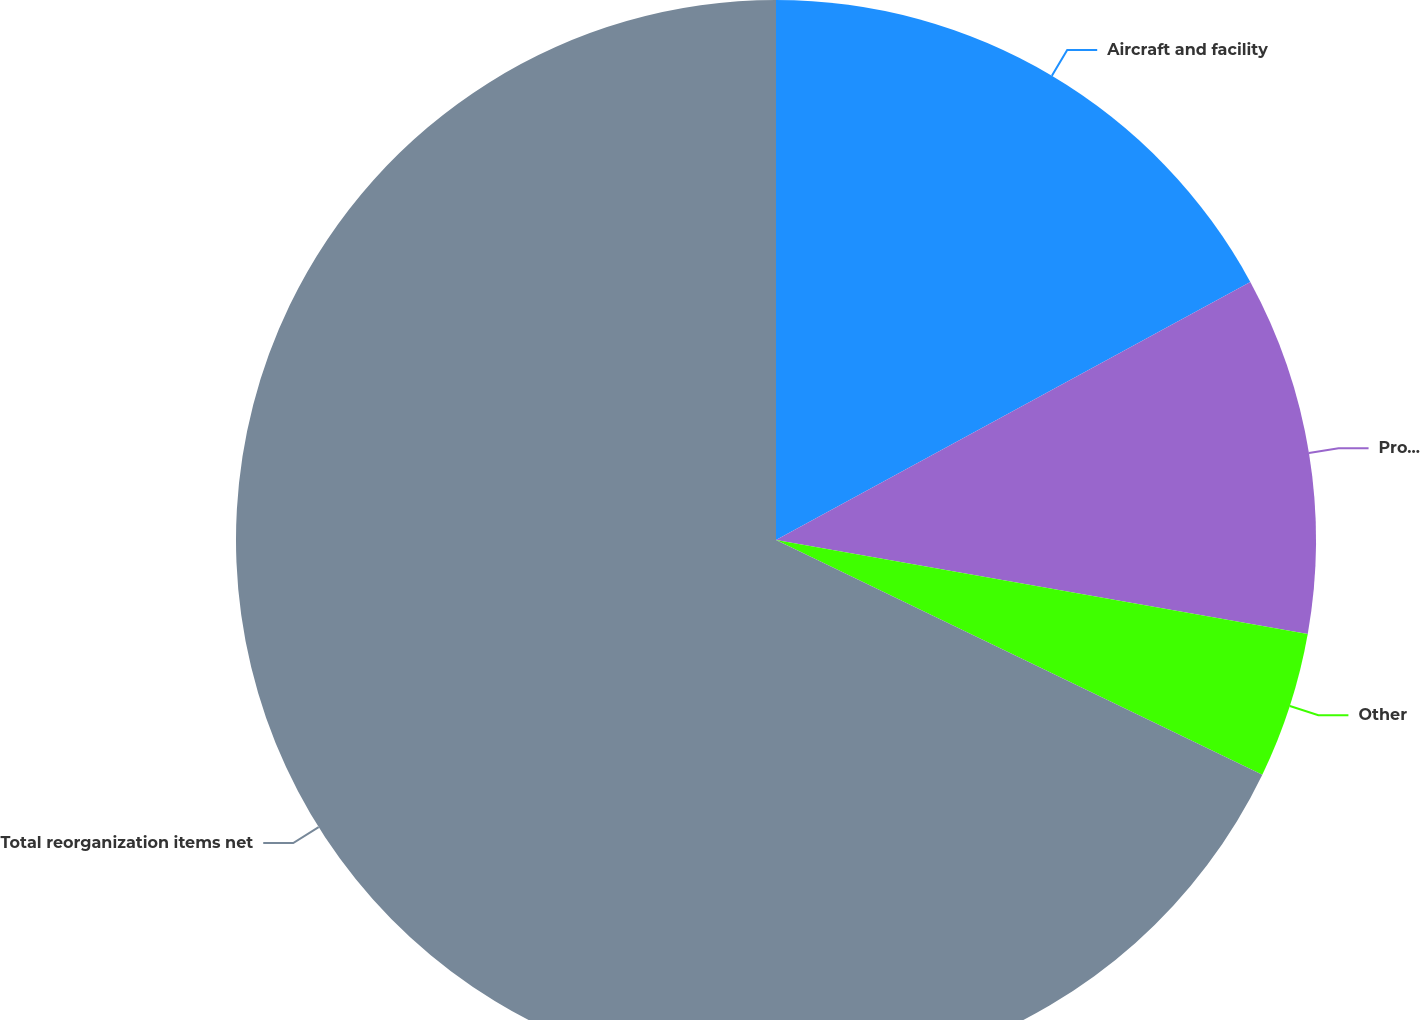Convert chart. <chart><loc_0><loc_0><loc_500><loc_500><pie_chart><fcel>Aircraft and facility<fcel>Professional fees<fcel>Other<fcel>Total reorganization items net<nl><fcel>17.07%<fcel>10.72%<fcel>4.37%<fcel>67.85%<nl></chart> 